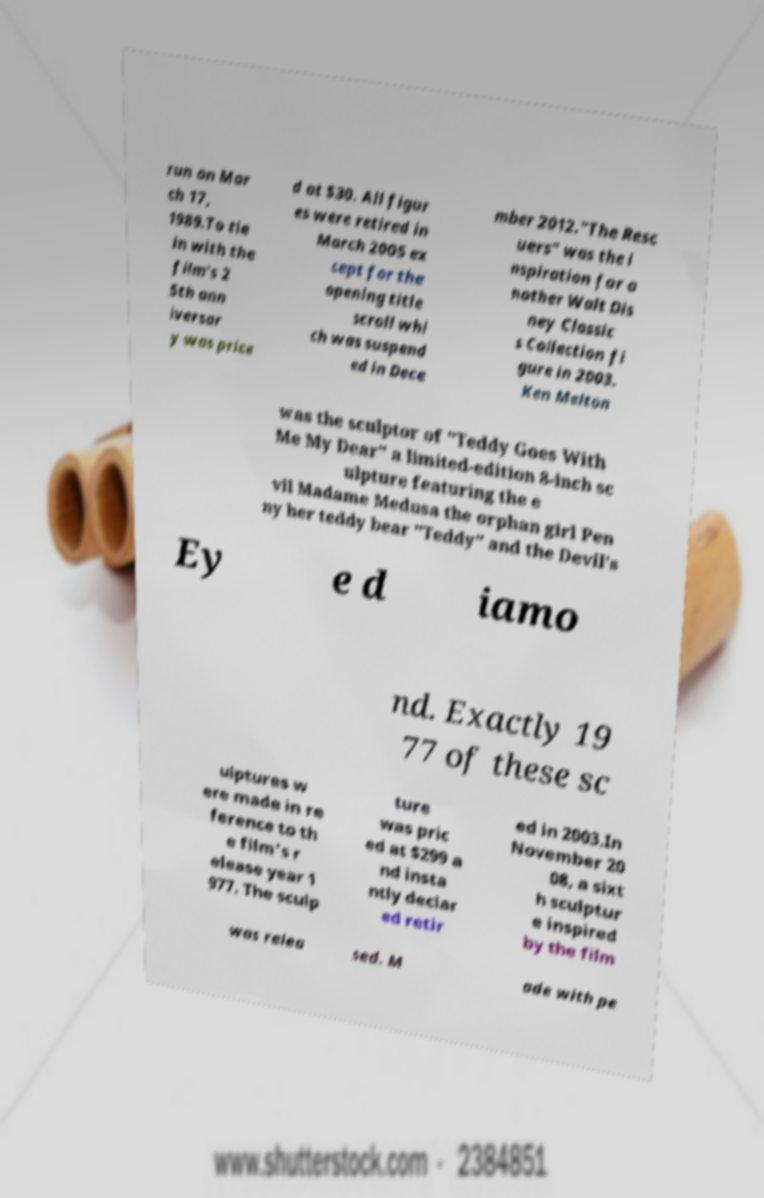Can you read and provide the text displayed in the image?This photo seems to have some interesting text. Can you extract and type it out for me? run on Mar ch 17, 1989.To tie in with the film's 2 5th ann iversar y was price d at $30. All figur es were retired in March 2005 ex cept for the opening title scroll whi ch was suspend ed in Dece mber 2012."The Resc uers" was the i nspiration for a nother Walt Dis ney Classic s Collection fi gure in 2003. Ken Melton was the sculptor of "Teddy Goes With Me My Dear" a limited-edition 8-inch sc ulpture featuring the e vil Madame Medusa the orphan girl Pen ny her teddy bear "Teddy" and the Devil's Ey e d iamo nd. Exactly 19 77 of these sc ulptures w ere made in re ference to th e film's r elease year 1 977. The sculp ture was pric ed at $299 a nd insta ntly declar ed retir ed in 2003.In November 20 08, a sixt h sculptur e inspired by the film was relea sed. M ade with pe 